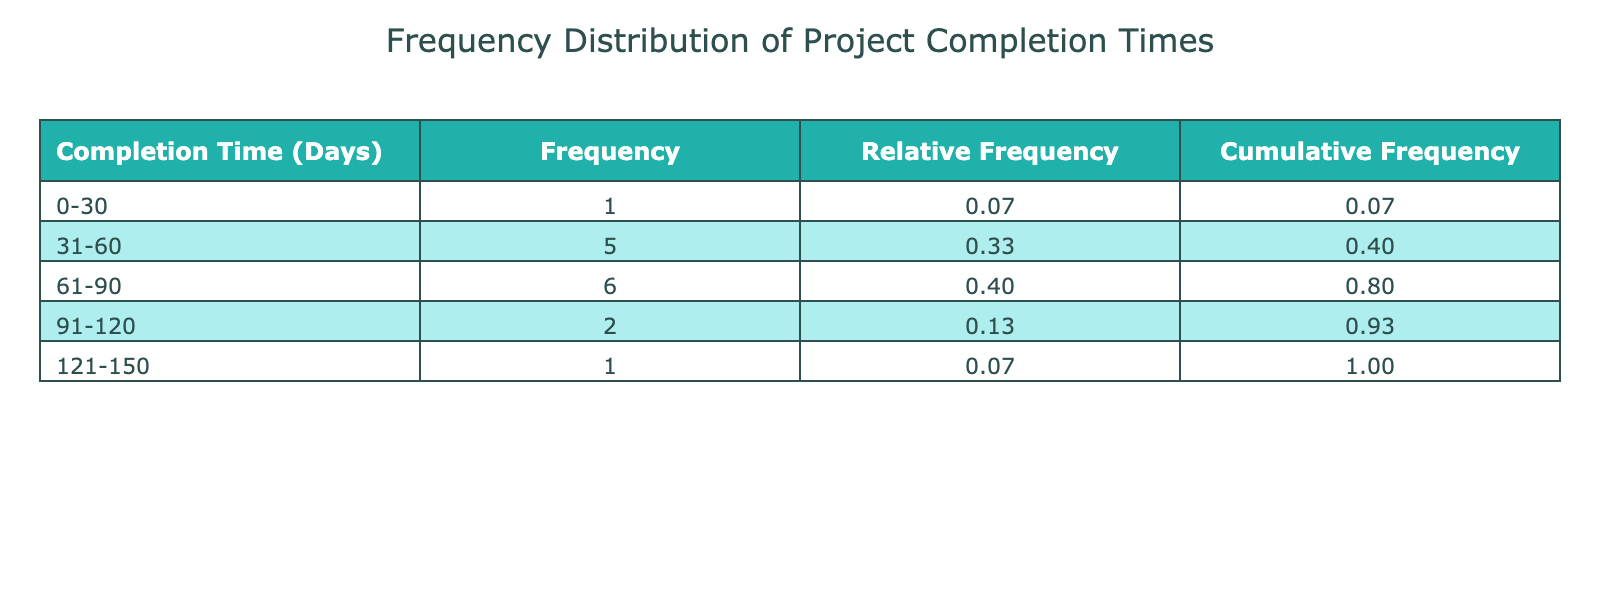What is the frequency of projects that took between 61 to 90 days to complete? Looking at the frequency distribution table, the category for 61-90 days shows a frequency of 4 projects.
Answer: 4 What is the relative frequency of projects completed in the 0-30 days category? The frequency of projects in the 0-30 days category is 1, and the total number of projects is 15, calculating the relative frequency gives 1/15 = 0.07.
Answer: 0.07 Are there more projects completed within 31 to 60 days than those completed between 91 to 120 days? In the table, the frequency for the 31-60 days category is 5 and for the 91-120 days category is 3, thus 5 > 3.
Answer: Yes What is the cumulative frequency of projects that took 90 days or more to complete? The cumulative frequency for the 91-120 days category is 3 (from 91-120) plus the frequency of 1 from the 121-150 days category, giving a total of 4 projects.
Answer: 4 What is the average completion time of projects that fall under the category of 61-90 days? The completion times for the 61-90 days category are 65, 70, 75, 80, and 90 days. Summing these gives 390 days, and dividing by 5 projects gives an average of 78 days.
Answer: 78 How many projects fall under the 121 to 150 days completion time bracket? The frequency of projects in the category for 121-150 days is 1, as indicated in the table.
Answer: 1 Which completion time category has the highest frequency of projects? By inspecting the frequency counts, the 31-60 days category has a frequency of 5, while other categories have a lower frequency, making it the highest.
Answer: 31-60 days What is the total number of projects that took less than 60 days to complete? Looking at the table, the frequencies for the 0-30 and 31-60 days categories are 1 and 5 respectively, summing these gives 1 + 5 = 6 projects in total.
Answer: 6 Is there any project that took exactly 120 days to complete? The table does not list any projects under the completion time of 120 days as there is one under 121-150 days only.
Answer: No 